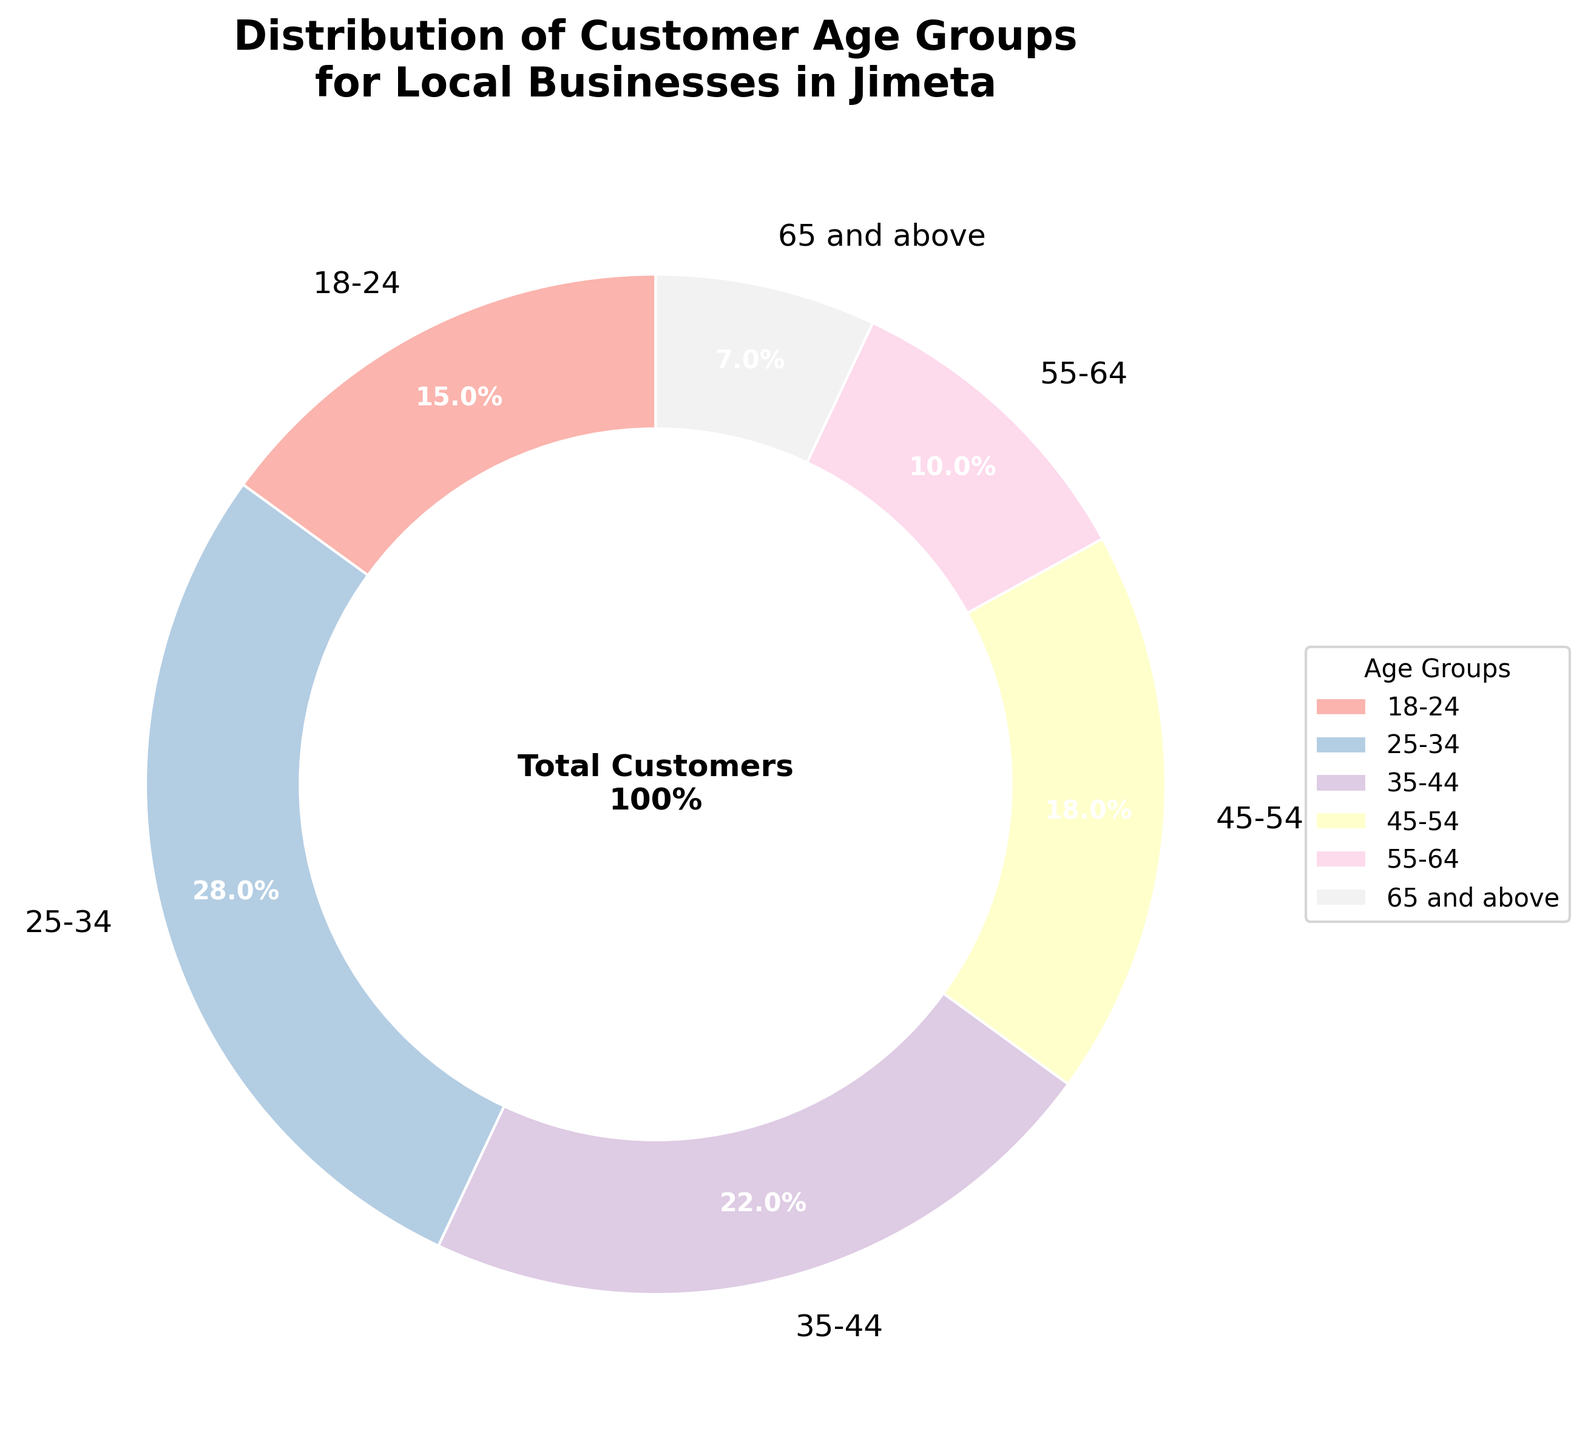What age group has the highest percentage of customers? By examining the percentages associated with each age group and comparing them, the age group 25-34 has the highest percentage at 28%.
Answer: 25-34 Which age group has the smallest percentage of customers? The age group 65 and above has the smallest percentage of customers at 7%.
Answer: 65 and above What is the combined percentage of customers in the 18-24 and 25-34 age groups? Adding the percentages of the 18-24 age group (15%) and the 25-34 age group (28%) results in 15 + 28 = 43%
Answer: 43% How does the percentage of customers aged 35-44 compare to those aged 45-54? The percentage of customers aged 35-44 is higher than that of the age group 45-54. Specifically, 35-44 has 22%, while 45-54 has 18%.
Answer: 35-44 Which age group occupies a little more than a quarter of the pie chart? By referring to the percentages, the age group 25-34 occupies 28% of the pie chart, which is slightly more than a quarter.
Answer: 25-34 What is the total percentage of customers aged 45 and above? Adding the percentages of age groups 45-54 (18%), 55-64 (10%), and 65 and above (7%), we get 18 + 10 + 7 = 35%
Answer: 35% Is the percentage of customers aged 55-64 greater than or less than one-fifth of the total pie chart? One-fifth of the pie chart is 20%, and the percentage of customers aged 55-64 is 10%, which is less than 20%.
Answer: Less than What color is used to represent the age group 18-24 in the chart? The colors are automatically chosen to distinguish different age groups; on examining the specific chart, find the color adjacent to the '18-24' text label.
Answer: Descriptive answer based on the actual look of the chart (e.g., light pink) What is the average percentage of the three most populous age groups? The three most populous age groups are 25-34 (28%), 35-44 (22%), and 45-54 (18%). To find the average: (28 + 22 + 18) / 3 = 68 / 3 ≈ 22.67%
Answer: 22.67% If we combine the age groups under 45 years old, what is their total percentage? Summing the percentages of the age groups 18-24 (15%), 25-34 (28%), and 35-44 (22%), we get 15 + 28 + 22 = 65%
Answer: 65% 